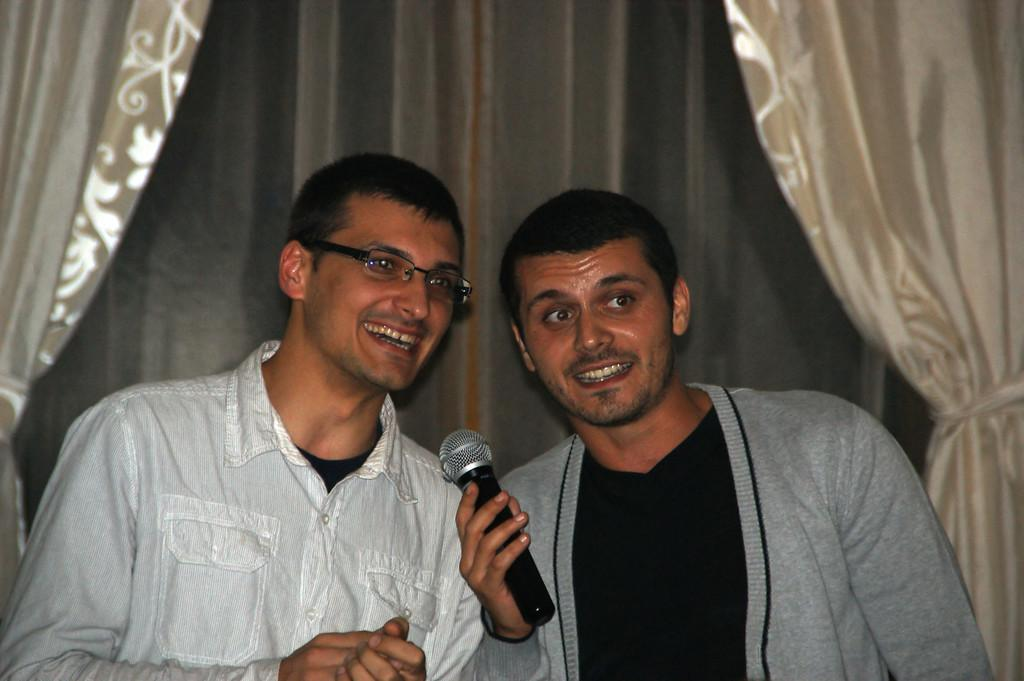How many people are in the image? There are two men in the image. What are the men doing in the image? The men are standing and holding microphones in their hands. What can be seen in the background of the image? There are curtains visible in the background of the image. What type of mitten is the man wearing on his left hand in the image? There are no mittens present in the image; the men are holding microphones in their hands. In which room of the building is the image taken? The image does not provide enough information to determine the specific room in which it was taken. 